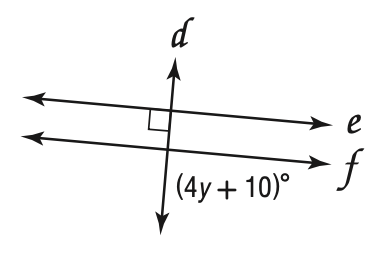Answer the mathemtical geometry problem and directly provide the correct option letter.
Question: Find y so that e \parallel f.
Choices: A: 20 B: 25 C: 80 D: 90 A 